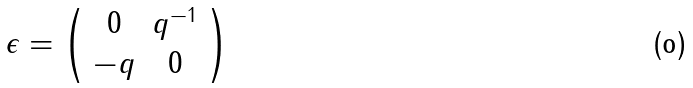<formula> <loc_0><loc_0><loc_500><loc_500>\epsilon = \left ( \begin{array} { c c } 0 & q ^ { - 1 } \\ - q & 0 \end{array} \right )</formula> 